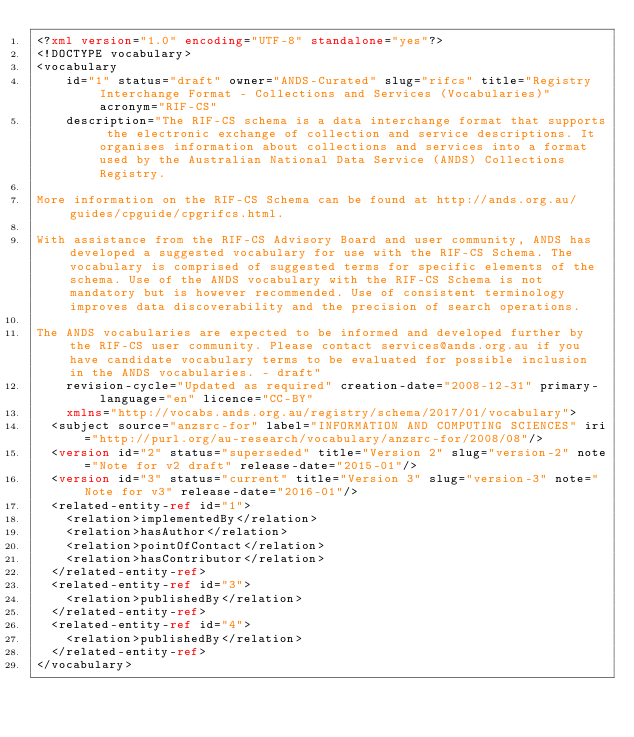<code> <loc_0><loc_0><loc_500><loc_500><_XML_><?xml version="1.0" encoding="UTF-8" standalone="yes"?>
<!DOCTYPE vocabulary>
<vocabulary
    id="1" status="draft" owner="ANDS-Curated" slug="rifcs" title="Registry Interchange Format - Collections and Services (Vocabularies)" acronym="RIF-CS"
    description="The RIF-CS schema is a data interchange format that supports the electronic exchange of collection and service descriptions. It organises information about collections and services into a format used by the Australian National Data Service (ANDS) Collections Registry.

More information on the RIF-CS Schema can be found at http://ands.org.au/guides/cpguide/cpgrifcs.html.

With assistance from the RIF-CS Advisory Board and user community, ANDS has developed a suggested vocabulary for use with the RIF-CS Schema. The vocabulary is comprised of suggested terms for specific elements of the schema. Use of the ANDS vocabulary with the RIF-CS Schema is not mandatory but is however recommended. Use of consistent terminology improves data discoverability and the precision of search operations.

The ANDS vocabularies are expected to be informed and developed further by the RIF-CS user community. Please contact services@ands.org.au if you have candidate vocabulary terms to be evaluated for possible inclusion in the ANDS vocabularies. - draft"
    revision-cycle="Updated as required" creation-date="2008-12-31" primary-language="en" licence="CC-BY"
    xmlns="http://vocabs.ands.org.au/registry/schema/2017/01/vocabulary">
  <subject source="anzsrc-for" label="INFORMATION AND COMPUTING SCIENCES" iri="http://purl.org/au-research/vocabulary/anzsrc-for/2008/08"/>
  <version id="2" status="superseded" title="Version 2" slug="version-2" note="Note for v2 draft" release-date="2015-01"/>
  <version id="3" status="current" title="Version 3" slug="version-3" note="Note for v3" release-date="2016-01"/>
  <related-entity-ref id="1">
    <relation>implementedBy</relation>
    <relation>hasAuthor</relation>
    <relation>pointOfContact</relation>
    <relation>hasContributor</relation>
  </related-entity-ref>
  <related-entity-ref id="3">
    <relation>publishedBy</relation>
  </related-entity-ref>
  <related-entity-ref id="4">
    <relation>publishedBy</relation>
  </related-entity-ref>
</vocabulary>
</code> 